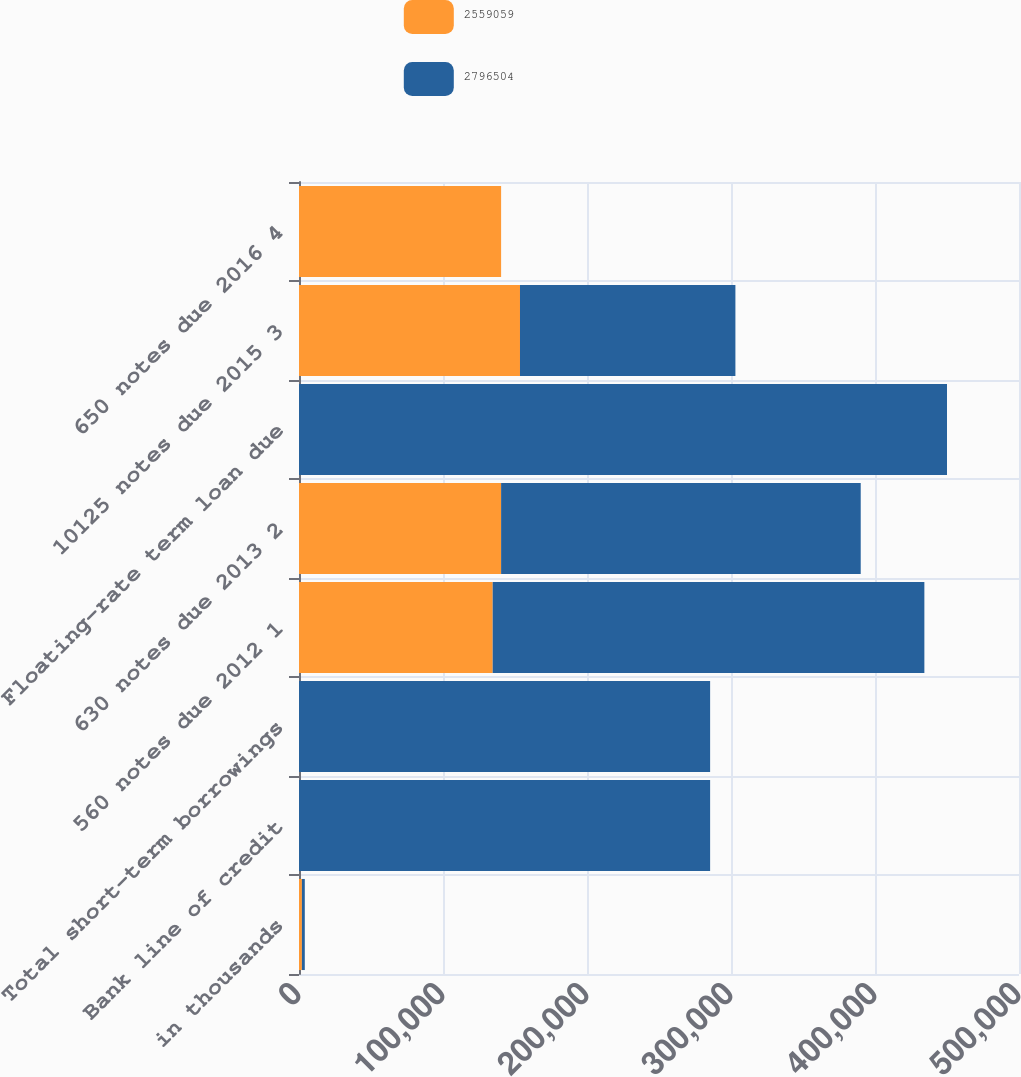Convert chart to OTSL. <chart><loc_0><loc_0><loc_500><loc_500><stacked_bar_chart><ecel><fcel>in thousands<fcel>Bank line of credit<fcel>Total short-term borrowings<fcel>560 notes due 2012 1<fcel>630 notes due 2013 2<fcel>Floating-rate term loan due<fcel>10125 notes due 2015 3<fcel>650 notes due 2016 4<nl><fcel>2.55906e+06<fcel>2011<fcel>0<fcel>0<fcel>134508<fcel>140352<fcel>0<fcel>153464<fcel>140352<nl><fcel>2.7965e+06<fcel>2010<fcel>285500<fcel>285500<fcel>299773<fcel>249729<fcel>450000<fcel>149597<fcel>0<nl></chart> 